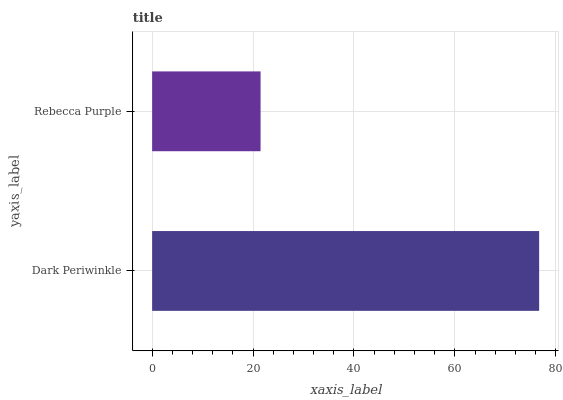Is Rebecca Purple the minimum?
Answer yes or no. Yes. Is Dark Periwinkle the maximum?
Answer yes or no. Yes. Is Rebecca Purple the maximum?
Answer yes or no. No. Is Dark Periwinkle greater than Rebecca Purple?
Answer yes or no. Yes. Is Rebecca Purple less than Dark Periwinkle?
Answer yes or no. Yes. Is Rebecca Purple greater than Dark Periwinkle?
Answer yes or no. No. Is Dark Periwinkle less than Rebecca Purple?
Answer yes or no. No. Is Dark Periwinkle the high median?
Answer yes or no. Yes. Is Rebecca Purple the low median?
Answer yes or no. Yes. Is Rebecca Purple the high median?
Answer yes or no. No. Is Dark Periwinkle the low median?
Answer yes or no. No. 